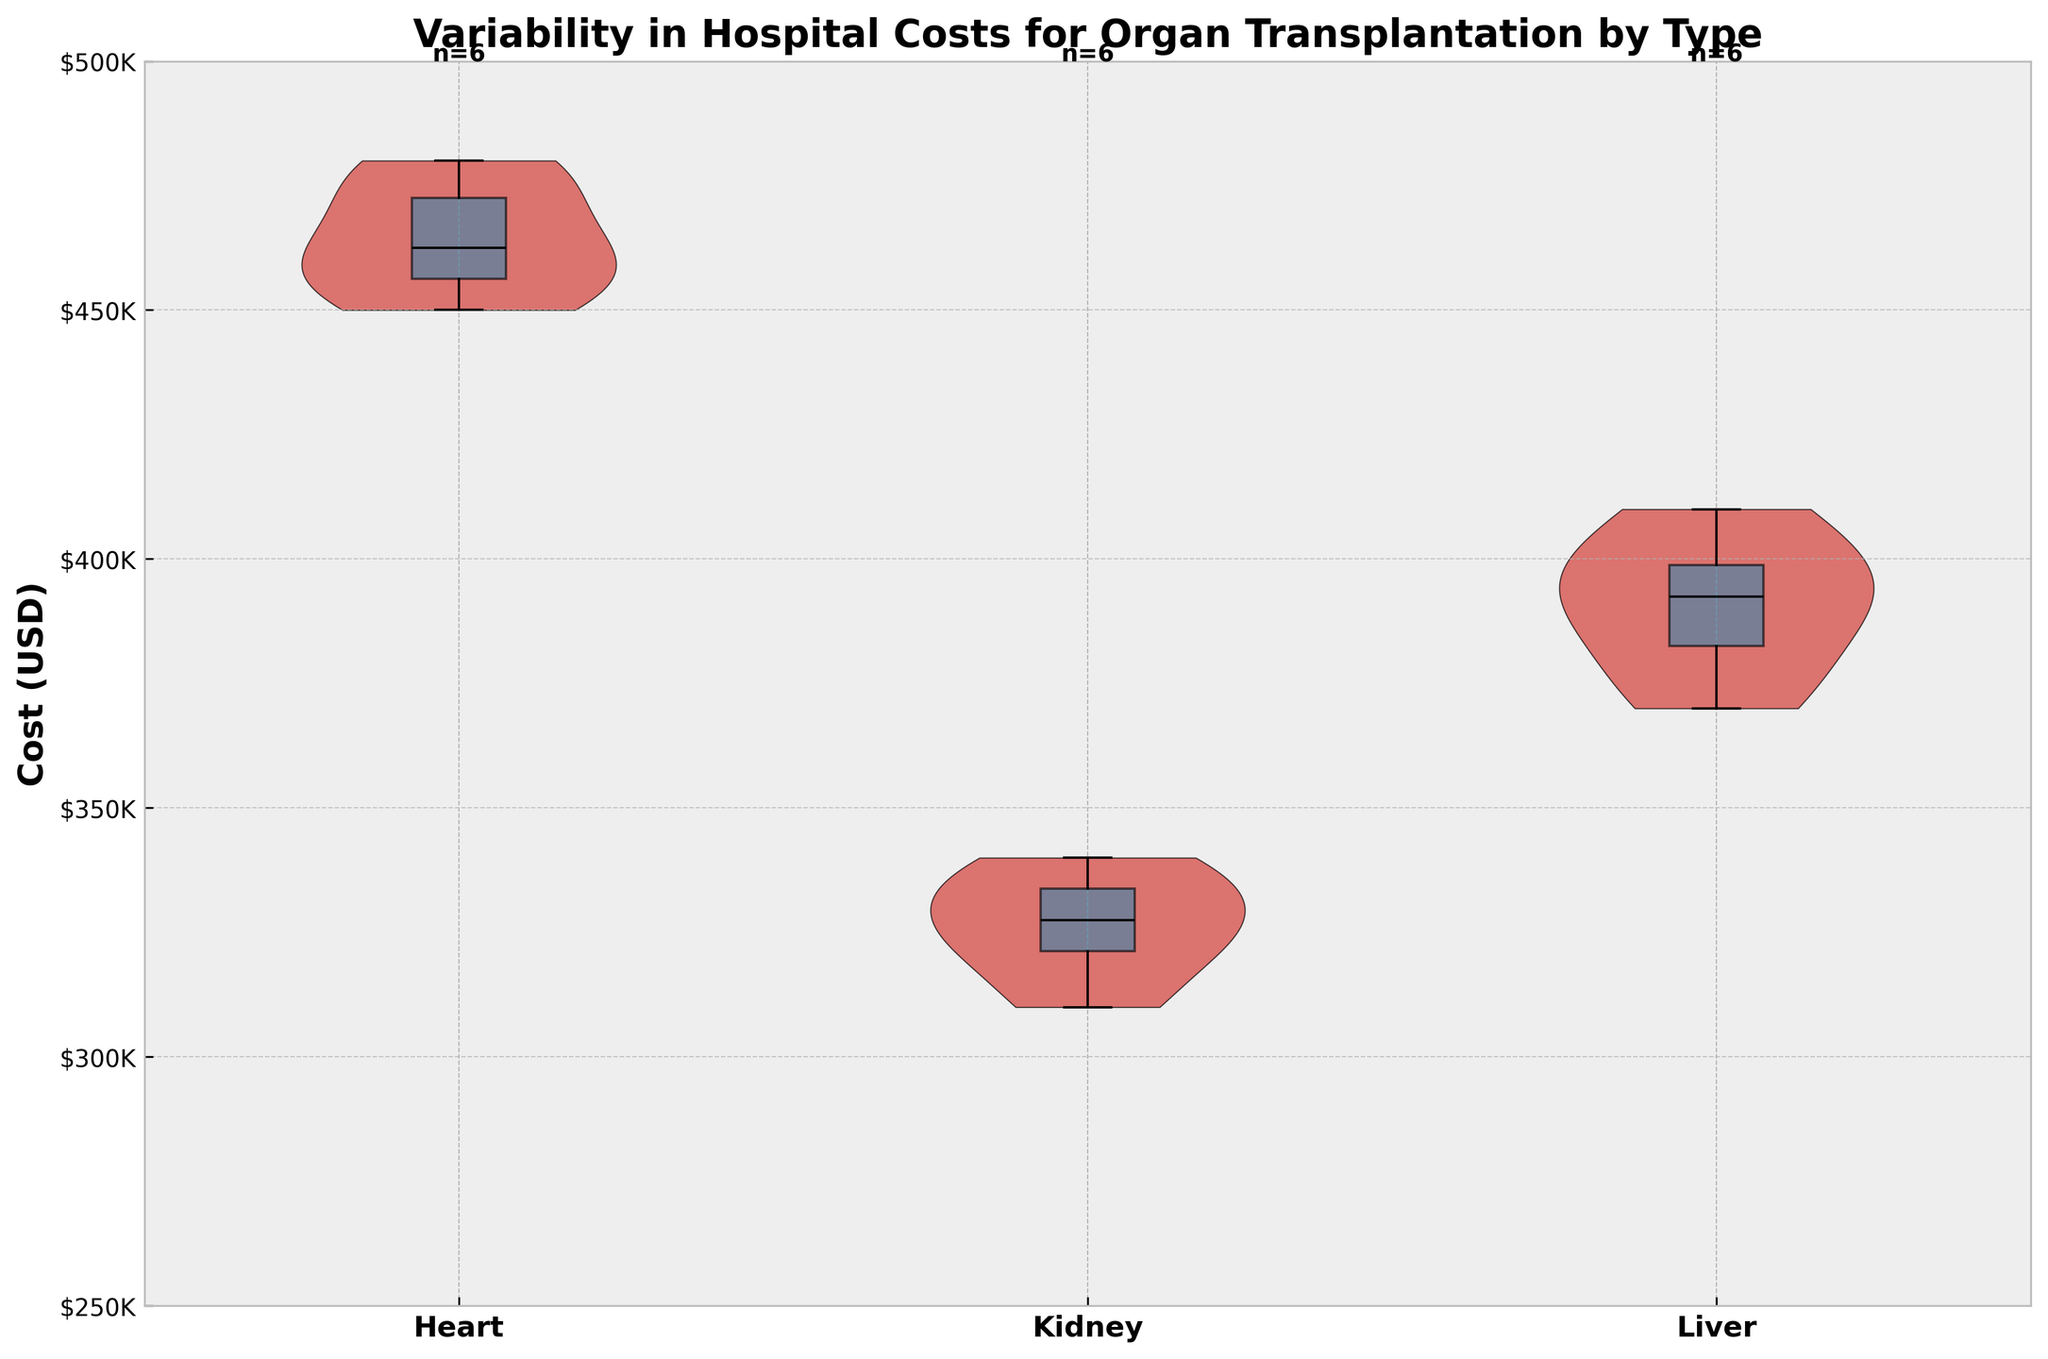How many transplant types are represented in the plot? The x-axis labels indicate the different transplant types. By counting them, we see "Heart," "Kidney," "Liver," which means there are 3 transplant types.
Answer: 3 What is the range of hospital costs for liver transplants? The range can be identified by looking at the highest and lowest points in the violin plot with the box plot overlay. For liver transplants, the highest cost appears to be just above $400,000 and the lowest cost is around $370,000.
Answer: $370,000 - $410,000 Which transplant type has the highest median cost? By observing the horizontal line in the middle of the box plots, we can compare the median costs of each transplant type. Among Heart, Kidney, and Liver, the Heart transplant has the highest median cost.
Answer: Heart What is the average number of data points per transplant type? There are 18 data points in total, and 3 transplant types. By dividing the total number of data points by the number of transplant types, we get an average of 18/3 = 6 data points per type.
Answer: 6 Which transplant type shows the greatest variability in hospital costs? The variability is represented by the width of the violin plots. The Liver transplant, with its wider violin plot, shows the greatest variability.
Answer: Liver What is the most common hospital cost range for kidney transplants? The density of the violin plot reveals the most common cost range. For Kidney transplants, most of the data points are clustered around $320,000 to $340,000.
Answer: $320,000 - $340,000 How does the cost variability of kidney transplants compare to heart transplants? The variability is reflected in the width of the violin plots. The violin plot for Kidney transplants is narrower compared to the Heart transplants, indicating less variability.
Answer: Kidney has less variability What is the lowest hospital cost recorded for heart transplants? The bottom horizontal line of the box plot indicates the lowest cost. For Heart transplants, it is around $450,000.
Answer: $450,000 Which state has the highest median cost for any transplant type? The state can be inferred by checking the labels and comparing the median lines in the box plots. The highest median cost is for Heart transplants, which is done in multiple states including NY, CA, OH, and TX. So, the exact state can't be determined without more data.
Answer: Cannot be determined Is the mean or the median higher for liver transplant costs? By observing the position of the box plot within the violin plot, the median for liver transplants falls around $395,000 while the mean can be inferred as slightly higher due to the skewness of the violin plot. Hence, the mean is higher.
Answer: Mean 